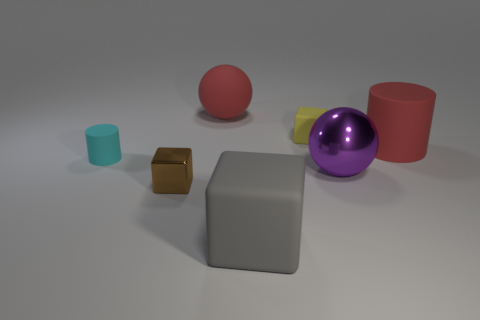Subtract all matte blocks. How many blocks are left? 1 Subtract all cubes. How many objects are left? 4 Add 2 yellow matte cubes. How many objects exist? 9 Subtract all yellow cubes. How many cubes are left? 2 Subtract 3 blocks. How many blocks are left? 0 Subtract all purple cylinders. How many blue spheres are left? 0 Subtract all small cyan rubber cylinders. Subtract all red matte things. How many objects are left? 4 Add 6 big matte objects. How many big matte objects are left? 9 Add 7 yellow cylinders. How many yellow cylinders exist? 7 Subtract 0 blue cylinders. How many objects are left? 7 